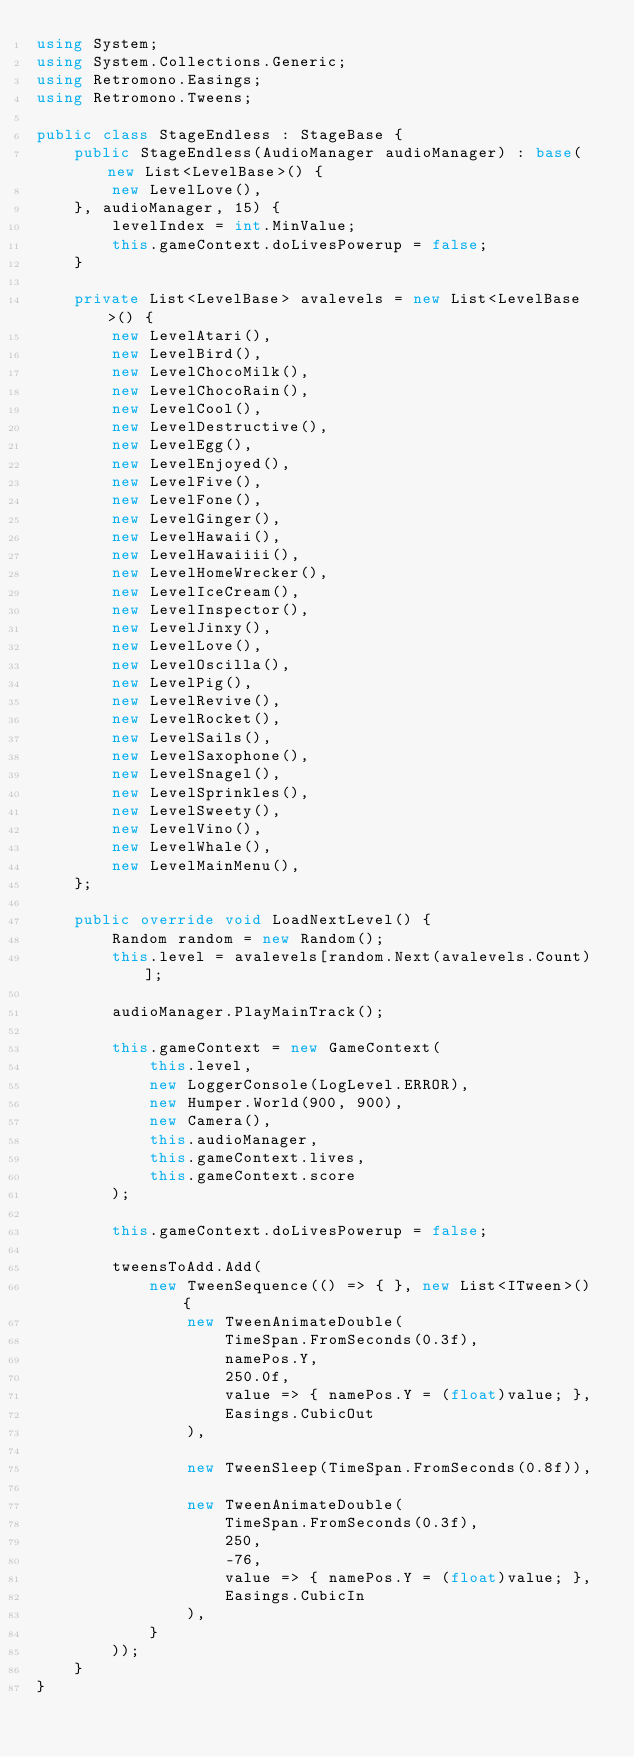<code> <loc_0><loc_0><loc_500><loc_500><_C#_>using System;
using System.Collections.Generic;
using Retromono.Easings;
using Retromono.Tweens;

public class StageEndless : StageBase {
	public StageEndless(AudioManager audioManager) : base(new List<LevelBase>() {
		new LevelLove(),
	}, audioManager, 15) {
		levelIndex = int.MinValue;
		this.gameContext.doLivesPowerup = false;
	}

	private List<LevelBase> avalevels = new List<LevelBase>() {
		new LevelAtari(),
		new LevelBird(),
		new LevelChocoMilk(),
		new LevelChocoRain(),
		new LevelCool(),
		new LevelDestructive(),
		new LevelEgg(),
		new LevelEnjoyed(),
		new LevelFive(),
		new LevelFone(),
		new LevelGinger(),
		new LevelHawaii(),
		new LevelHawaiiii(),
		new LevelHomeWrecker(),
		new LevelIceCream(),
		new LevelInspector(),
		new LevelJinxy(),
		new LevelLove(),
		new LevelOscilla(),
		new LevelPig(),
		new LevelRevive(),
		new LevelRocket(),
		new LevelSails(),
		new LevelSaxophone(),
		new LevelSnagel(),
		new LevelSprinkles(),
		new LevelSweety(),
		new LevelVino(),
		new LevelWhale(),
		new LevelMainMenu(),
	};

	public override void LoadNextLevel() {
		Random random = new Random();
		this.level = avalevels[random.Next(avalevels.Count)];

		audioManager.PlayMainTrack();

		this.gameContext = new GameContext(
			this.level,
			new LoggerConsole(LogLevel.ERROR),
			new Humper.World(900, 900),
			new Camera(),
			this.audioManager,
			this.gameContext.lives,
			this.gameContext.score
		);

		this.gameContext.doLivesPowerup = false;

		tweensToAdd.Add(
			new TweenSequence(() => { }, new List<ITween>() {
				new TweenAnimateDouble(
					TimeSpan.FromSeconds(0.3f),
					namePos.Y,
					250.0f,
					value => { namePos.Y = (float)value; },
					Easings.CubicOut
				),

				new TweenSleep(TimeSpan.FromSeconds(0.8f)),

				new TweenAnimateDouble(
					TimeSpan.FromSeconds(0.3f),
					250,
					-76,
					value => { namePos.Y = (float)value; },
					Easings.CubicIn
				),
			}
		));
	}
}</code> 